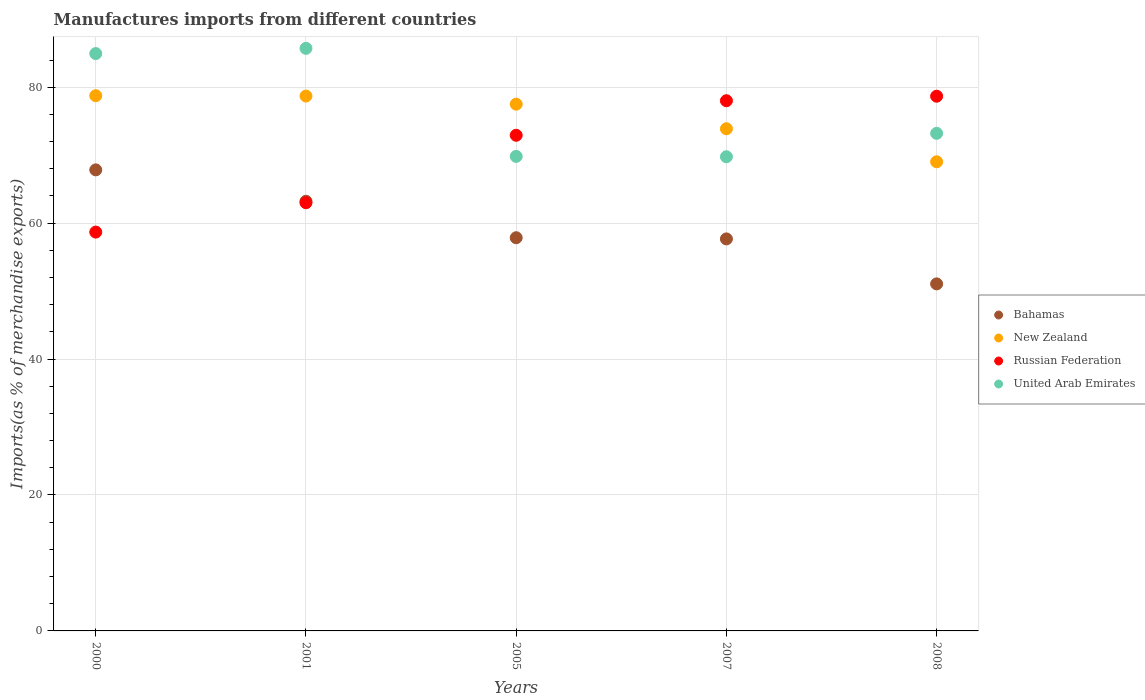What is the percentage of imports to different countries in United Arab Emirates in 2005?
Make the answer very short. 69.82. Across all years, what is the maximum percentage of imports to different countries in New Zealand?
Offer a terse response. 78.75. Across all years, what is the minimum percentage of imports to different countries in United Arab Emirates?
Make the answer very short. 69.77. In which year was the percentage of imports to different countries in Russian Federation maximum?
Provide a succinct answer. 2008. What is the total percentage of imports to different countries in United Arab Emirates in the graph?
Offer a terse response. 383.45. What is the difference between the percentage of imports to different countries in Russian Federation in 2005 and that in 2008?
Provide a succinct answer. -5.75. What is the difference between the percentage of imports to different countries in Bahamas in 2001 and the percentage of imports to different countries in New Zealand in 2008?
Offer a terse response. -5.81. What is the average percentage of imports to different countries in Bahamas per year?
Your answer should be very brief. 59.53. In the year 2000, what is the difference between the percentage of imports to different countries in Russian Federation and percentage of imports to different countries in United Arab Emirates?
Your answer should be very brief. -26.26. In how many years, is the percentage of imports to different countries in Bahamas greater than 4 %?
Give a very brief answer. 5. What is the ratio of the percentage of imports to different countries in Bahamas in 2000 to that in 2001?
Provide a short and direct response. 1.07. Is the difference between the percentage of imports to different countries in Russian Federation in 2000 and 2007 greater than the difference between the percentage of imports to different countries in United Arab Emirates in 2000 and 2007?
Give a very brief answer. No. What is the difference between the highest and the second highest percentage of imports to different countries in United Arab Emirates?
Ensure brevity in your answer.  0.77. What is the difference between the highest and the lowest percentage of imports to different countries in United Arab Emirates?
Provide a succinct answer. 15.95. In how many years, is the percentage of imports to different countries in Russian Federation greater than the average percentage of imports to different countries in Russian Federation taken over all years?
Ensure brevity in your answer.  3. Is it the case that in every year, the sum of the percentage of imports to different countries in Russian Federation and percentage of imports to different countries in United Arab Emirates  is greater than the sum of percentage of imports to different countries in New Zealand and percentage of imports to different countries in Bahamas?
Ensure brevity in your answer.  No. Is it the case that in every year, the sum of the percentage of imports to different countries in Bahamas and percentage of imports to different countries in New Zealand  is greater than the percentage of imports to different countries in Russian Federation?
Keep it short and to the point. Yes. Does the percentage of imports to different countries in United Arab Emirates monotonically increase over the years?
Your answer should be very brief. No. How many years are there in the graph?
Keep it short and to the point. 5. Are the values on the major ticks of Y-axis written in scientific E-notation?
Your answer should be very brief. No. Where does the legend appear in the graph?
Your answer should be very brief. Center right. How are the legend labels stacked?
Give a very brief answer. Vertical. What is the title of the graph?
Your response must be concise. Manufactures imports from different countries. Does "Pakistan" appear as one of the legend labels in the graph?
Ensure brevity in your answer.  No. What is the label or title of the X-axis?
Keep it short and to the point. Years. What is the label or title of the Y-axis?
Your answer should be compact. Imports(as % of merchandise exports). What is the Imports(as % of merchandise exports) of Bahamas in 2000?
Offer a very short reply. 67.84. What is the Imports(as % of merchandise exports) of New Zealand in 2000?
Ensure brevity in your answer.  78.75. What is the Imports(as % of merchandise exports) of Russian Federation in 2000?
Your answer should be very brief. 58.68. What is the Imports(as % of merchandise exports) of United Arab Emirates in 2000?
Offer a terse response. 84.94. What is the Imports(as % of merchandise exports) in Bahamas in 2001?
Provide a succinct answer. 63.22. What is the Imports(as % of merchandise exports) of New Zealand in 2001?
Offer a very short reply. 78.7. What is the Imports(as % of merchandise exports) of Russian Federation in 2001?
Your answer should be compact. 63. What is the Imports(as % of merchandise exports) in United Arab Emirates in 2001?
Keep it short and to the point. 85.72. What is the Imports(as % of merchandise exports) in Bahamas in 2005?
Your answer should be very brief. 57.85. What is the Imports(as % of merchandise exports) in New Zealand in 2005?
Offer a terse response. 77.5. What is the Imports(as % of merchandise exports) of Russian Federation in 2005?
Provide a short and direct response. 72.92. What is the Imports(as % of merchandise exports) in United Arab Emirates in 2005?
Offer a very short reply. 69.82. What is the Imports(as % of merchandise exports) of Bahamas in 2007?
Make the answer very short. 57.68. What is the Imports(as % of merchandise exports) of New Zealand in 2007?
Your answer should be very brief. 73.89. What is the Imports(as % of merchandise exports) of Russian Federation in 2007?
Ensure brevity in your answer.  78.01. What is the Imports(as % of merchandise exports) of United Arab Emirates in 2007?
Your answer should be compact. 69.77. What is the Imports(as % of merchandise exports) of Bahamas in 2008?
Offer a terse response. 51.06. What is the Imports(as % of merchandise exports) in New Zealand in 2008?
Your response must be concise. 69.03. What is the Imports(as % of merchandise exports) in Russian Federation in 2008?
Provide a short and direct response. 78.67. What is the Imports(as % of merchandise exports) in United Arab Emirates in 2008?
Your answer should be very brief. 73.21. Across all years, what is the maximum Imports(as % of merchandise exports) in Bahamas?
Your response must be concise. 67.84. Across all years, what is the maximum Imports(as % of merchandise exports) in New Zealand?
Provide a succinct answer. 78.75. Across all years, what is the maximum Imports(as % of merchandise exports) in Russian Federation?
Your response must be concise. 78.67. Across all years, what is the maximum Imports(as % of merchandise exports) of United Arab Emirates?
Offer a terse response. 85.72. Across all years, what is the minimum Imports(as % of merchandise exports) in Bahamas?
Your answer should be very brief. 51.06. Across all years, what is the minimum Imports(as % of merchandise exports) in New Zealand?
Offer a terse response. 69.03. Across all years, what is the minimum Imports(as % of merchandise exports) of Russian Federation?
Your answer should be compact. 58.68. Across all years, what is the minimum Imports(as % of merchandise exports) in United Arab Emirates?
Ensure brevity in your answer.  69.77. What is the total Imports(as % of merchandise exports) in Bahamas in the graph?
Make the answer very short. 297.65. What is the total Imports(as % of merchandise exports) of New Zealand in the graph?
Keep it short and to the point. 377.86. What is the total Imports(as % of merchandise exports) in Russian Federation in the graph?
Offer a very short reply. 351.29. What is the total Imports(as % of merchandise exports) of United Arab Emirates in the graph?
Your response must be concise. 383.45. What is the difference between the Imports(as % of merchandise exports) in Bahamas in 2000 and that in 2001?
Your answer should be compact. 4.62. What is the difference between the Imports(as % of merchandise exports) of New Zealand in 2000 and that in 2001?
Your answer should be very brief. 0.05. What is the difference between the Imports(as % of merchandise exports) in Russian Federation in 2000 and that in 2001?
Your answer should be very brief. -4.32. What is the difference between the Imports(as % of merchandise exports) in United Arab Emirates in 2000 and that in 2001?
Give a very brief answer. -0.77. What is the difference between the Imports(as % of merchandise exports) in Bahamas in 2000 and that in 2005?
Keep it short and to the point. 9.99. What is the difference between the Imports(as % of merchandise exports) of New Zealand in 2000 and that in 2005?
Provide a succinct answer. 1.25. What is the difference between the Imports(as % of merchandise exports) in Russian Federation in 2000 and that in 2005?
Your answer should be very brief. -14.24. What is the difference between the Imports(as % of merchandise exports) of United Arab Emirates in 2000 and that in 2005?
Your answer should be very brief. 15.13. What is the difference between the Imports(as % of merchandise exports) in Bahamas in 2000 and that in 2007?
Make the answer very short. 10.16. What is the difference between the Imports(as % of merchandise exports) in New Zealand in 2000 and that in 2007?
Give a very brief answer. 4.86. What is the difference between the Imports(as % of merchandise exports) of Russian Federation in 2000 and that in 2007?
Provide a succinct answer. -19.33. What is the difference between the Imports(as % of merchandise exports) in United Arab Emirates in 2000 and that in 2007?
Give a very brief answer. 15.18. What is the difference between the Imports(as % of merchandise exports) in Bahamas in 2000 and that in 2008?
Your answer should be compact. 16.77. What is the difference between the Imports(as % of merchandise exports) in New Zealand in 2000 and that in 2008?
Offer a terse response. 9.72. What is the difference between the Imports(as % of merchandise exports) of Russian Federation in 2000 and that in 2008?
Offer a terse response. -19.99. What is the difference between the Imports(as % of merchandise exports) of United Arab Emirates in 2000 and that in 2008?
Your answer should be very brief. 11.74. What is the difference between the Imports(as % of merchandise exports) of Bahamas in 2001 and that in 2005?
Provide a short and direct response. 5.37. What is the difference between the Imports(as % of merchandise exports) in New Zealand in 2001 and that in 2005?
Keep it short and to the point. 1.2. What is the difference between the Imports(as % of merchandise exports) in Russian Federation in 2001 and that in 2005?
Your answer should be compact. -9.93. What is the difference between the Imports(as % of merchandise exports) in United Arab Emirates in 2001 and that in 2005?
Offer a terse response. 15.9. What is the difference between the Imports(as % of merchandise exports) of Bahamas in 2001 and that in 2007?
Provide a short and direct response. 5.54. What is the difference between the Imports(as % of merchandise exports) of New Zealand in 2001 and that in 2007?
Offer a terse response. 4.81. What is the difference between the Imports(as % of merchandise exports) in Russian Federation in 2001 and that in 2007?
Ensure brevity in your answer.  -15.01. What is the difference between the Imports(as % of merchandise exports) in United Arab Emirates in 2001 and that in 2007?
Ensure brevity in your answer.  15.95. What is the difference between the Imports(as % of merchandise exports) of Bahamas in 2001 and that in 2008?
Offer a very short reply. 12.16. What is the difference between the Imports(as % of merchandise exports) in New Zealand in 2001 and that in 2008?
Make the answer very short. 9.67. What is the difference between the Imports(as % of merchandise exports) of Russian Federation in 2001 and that in 2008?
Provide a short and direct response. -15.68. What is the difference between the Imports(as % of merchandise exports) in United Arab Emirates in 2001 and that in 2008?
Your response must be concise. 12.51. What is the difference between the Imports(as % of merchandise exports) in Bahamas in 2005 and that in 2007?
Provide a succinct answer. 0.17. What is the difference between the Imports(as % of merchandise exports) of New Zealand in 2005 and that in 2007?
Provide a succinct answer. 3.62. What is the difference between the Imports(as % of merchandise exports) in Russian Federation in 2005 and that in 2007?
Provide a short and direct response. -5.08. What is the difference between the Imports(as % of merchandise exports) in United Arab Emirates in 2005 and that in 2007?
Offer a terse response. 0.05. What is the difference between the Imports(as % of merchandise exports) in Bahamas in 2005 and that in 2008?
Offer a terse response. 6.79. What is the difference between the Imports(as % of merchandise exports) in New Zealand in 2005 and that in 2008?
Keep it short and to the point. 8.47. What is the difference between the Imports(as % of merchandise exports) of Russian Federation in 2005 and that in 2008?
Offer a very short reply. -5.75. What is the difference between the Imports(as % of merchandise exports) of United Arab Emirates in 2005 and that in 2008?
Provide a succinct answer. -3.39. What is the difference between the Imports(as % of merchandise exports) of Bahamas in 2007 and that in 2008?
Give a very brief answer. 6.62. What is the difference between the Imports(as % of merchandise exports) of New Zealand in 2007 and that in 2008?
Provide a short and direct response. 4.86. What is the difference between the Imports(as % of merchandise exports) of Russian Federation in 2007 and that in 2008?
Keep it short and to the point. -0.66. What is the difference between the Imports(as % of merchandise exports) in United Arab Emirates in 2007 and that in 2008?
Make the answer very short. -3.44. What is the difference between the Imports(as % of merchandise exports) in Bahamas in 2000 and the Imports(as % of merchandise exports) in New Zealand in 2001?
Ensure brevity in your answer.  -10.86. What is the difference between the Imports(as % of merchandise exports) of Bahamas in 2000 and the Imports(as % of merchandise exports) of Russian Federation in 2001?
Offer a very short reply. 4.84. What is the difference between the Imports(as % of merchandise exports) in Bahamas in 2000 and the Imports(as % of merchandise exports) in United Arab Emirates in 2001?
Your answer should be compact. -17.88. What is the difference between the Imports(as % of merchandise exports) in New Zealand in 2000 and the Imports(as % of merchandise exports) in Russian Federation in 2001?
Provide a short and direct response. 15.75. What is the difference between the Imports(as % of merchandise exports) of New Zealand in 2000 and the Imports(as % of merchandise exports) of United Arab Emirates in 2001?
Give a very brief answer. -6.97. What is the difference between the Imports(as % of merchandise exports) in Russian Federation in 2000 and the Imports(as % of merchandise exports) in United Arab Emirates in 2001?
Provide a succinct answer. -27.03. What is the difference between the Imports(as % of merchandise exports) in Bahamas in 2000 and the Imports(as % of merchandise exports) in New Zealand in 2005?
Keep it short and to the point. -9.67. What is the difference between the Imports(as % of merchandise exports) in Bahamas in 2000 and the Imports(as % of merchandise exports) in Russian Federation in 2005?
Ensure brevity in your answer.  -5.09. What is the difference between the Imports(as % of merchandise exports) in Bahamas in 2000 and the Imports(as % of merchandise exports) in United Arab Emirates in 2005?
Your answer should be compact. -1.98. What is the difference between the Imports(as % of merchandise exports) of New Zealand in 2000 and the Imports(as % of merchandise exports) of Russian Federation in 2005?
Provide a succinct answer. 5.82. What is the difference between the Imports(as % of merchandise exports) of New Zealand in 2000 and the Imports(as % of merchandise exports) of United Arab Emirates in 2005?
Keep it short and to the point. 8.93. What is the difference between the Imports(as % of merchandise exports) of Russian Federation in 2000 and the Imports(as % of merchandise exports) of United Arab Emirates in 2005?
Your response must be concise. -11.14. What is the difference between the Imports(as % of merchandise exports) in Bahamas in 2000 and the Imports(as % of merchandise exports) in New Zealand in 2007?
Provide a succinct answer. -6.05. What is the difference between the Imports(as % of merchandise exports) of Bahamas in 2000 and the Imports(as % of merchandise exports) of Russian Federation in 2007?
Provide a succinct answer. -10.17. What is the difference between the Imports(as % of merchandise exports) of Bahamas in 2000 and the Imports(as % of merchandise exports) of United Arab Emirates in 2007?
Provide a short and direct response. -1.93. What is the difference between the Imports(as % of merchandise exports) in New Zealand in 2000 and the Imports(as % of merchandise exports) in Russian Federation in 2007?
Give a very brief answer. 0.74. What is the difference between the Imports(as % of merchandise exports) of New Zealand in 2000 and the Imports(as % of merchandise exports) of United Arab Emirates in 2007?
Give a very brief answer. 8.98. What is the difference between the Imports(as % of merchandise exports) in Russian Federation in 2000 and the Imports(as % of merchandise exports) in United Arab Emirates in 2007?
Your answer should be very brief. -11.08. What is the difference between the Imports(as % of merchandise exports) in Bahamas in 2000 and the Imports(as % of merchandise exports) in New Zealand in 2008?
Give a very brief answer. -1.19. What is the difference between the Imports(as % of merchandise exports) of Bahamas in 2000 and the Imports(as % of merchandise exports) of Russian Federation in 2008?
Provide a succinct answer. -10.84. What is the difference between the Imports(as % of merchandise exports) of Bahamas in 2000 and the Imports(as % of merchandise exports) of United Arab Emirates in 2008?
Provide a short and direct response. -5.37. What is the difference between the Imports(as % of merchandise exports) in New Zealand in 2000 and the Imports(as % of merchandise exports) in Russian Federation in 2008?
Offer a terse response. 0.07. What is the difference between the Imports(as % of merchandise exports) of New Zealand in 2000 and the Imports(as % of merchandise exports) of United Arab Emirates in 2008?
Make the answer very short. 5.54. What is the difference between the Imports(as % of merchandise exports) in Russian Federation in 2000 and the Imports(as % of merchandise exports) in United Arab Emirates in 2008?
Provide a short and direct response. -14.53. What is the difference between the Imports(as % of merchandise exports) of Bahamas in 2001 and the Imports(as % of merchandise exports) of New Zealand in 2005?
Offer a terse response. -14.28. What is the difference between the Imports(as % of merchandise exports) in Bahamas in 2001 and the Imports(as % of merchandise exports) in Russian Federation in 2005?
Provide a short and direct response. -9.71. What is the difference between the Imports(as % of merchandise exports) in Bahamas in 2001 and the Imports(as % of merchandise exports) in United Arab Emirates in 2005?
Offer a very short reply. -6.6. What is the difference between the Imports(as % of merchandise exports) of New Zealand in 2001 and the Imports(as % of merchandise exports) of Russian Federation in 2005?
Offer a terse response. 5.77. What is the difference between the Imports(as % of merchandise exports) of New Zealand in 2001 and the Imports(as % of merchandise exports) of United Arab Emirates in 2005?
Keep it short and to the point. 8.88. What is the difference between the Imports(as % of merchandise exports) of Russian Federation in 2001 and the Imports(as % of merchandise exports) of United Arab Emirates in 2005?
Give a very brief answer. -6.82. What is the difference between the Imports(as % of merchandise exports) of Bahamas in 2001 and the Imports(as % of merchandise exports) of New Zealand in 2007?
Your response must be concise. -10.67. What is the difference between the Imports(as % of merchandise exports) in Bahamas in 2001 and the Imports(as % of merchandise exports) in Russian Federation in 2007?
Give a very brief answer. -14.79. What is the difference between the Imports(as % of merchandise exports) of Bahamas in 2001 and the Imports(as % of merchandise exports) of United Arab Emirates in 2007?
Offer a very short reply. -6.55. What is the difference between the Imports(as % of merchandise exports) of New Zealand in 2001 and the Imports(as % of merchandise exports) of Russian Federation in 2007?
Your answer should be very brief. 0.69. What is the difference between the Imports(as % of merchandise exports) in New Zealand in 2001 and the Imports(as % of merchandise exports) in United Arab Emirates in 2007?
Provide a succinct answer. 8.93. What is the difference between the Imports(as % of merchandise exports) in Russian Federation in 2001 and the Imports(as % of merchandise exports) in United Arab Emirates in 2007?
Your response must be concise. -6.77. What is the difference between the Imports(as % of merchandise exports) of Bahamas in 2001 and the Imports(as % of merchandise exports) of New Zealand in 2008?
Ensure brevity in your answer.  -5.81. What is the difference between the Imports(as % of merchandise exports) of Bahamas in 2001 and the Imports(as % of merchandise exports) of Russian Federation in 2008?
Provide a short and direct response. -15.46. What is the difference between the Imports(as % of merchandise exports) of Bahamas in 2001 and the Imports(as % of merchandise exports) of United Arab Emirates in 2008?
Offer a terse response. -9.99. What is the difference between the Imports(as % of merchandise exports) of New Zealand in 2001 and the Imports(as % of merchandise exports) of Russian Federation in 2008?
Your answer should be very brief. 0.02. What is the difference between the Imports(as % of merchandise exports) in New Zealand in 2001 and the Imports(as % of merchandise exports) in United Arab Emirates in 2008?
Ensure brevity in your answer.  5.49. What is the difference between the Imports(as % of merchandise exports) of Russian Federation in 2001 and the Imports(as % of merchandise exports) of United Arab Emirates in 2008?
Give a very brief answer. -10.21. What is the difference between the Imports(as % of merchandise exports) of Bahamas in 2005 and the Imports(as % of merchandise exports) of New Zealand in 2007?
Your answer should be compact. -16.04. What is the difference between the Imports(as % of merchandise exports) in Bahamas in 2005 and the Imports(as % of merchandise exports) in Russian Federation in 2007?
Offer a very short reply. -20.16. What is the difference between the Imports(as % of merchandise exports) of Bahamas in 2005 and the Imports(as % of merchandise exports) of United Arab Emirates in 2007?
Provide a short and direct response. -11.91. What is the difference between the Imports(as % of merchandise exports) of New Zealand in 2005 and the Imports(as % of merchandise exports) of Russian Federation in 2007?
Your answer should be very brief. -0.51. What is the difference between the Imports(as % of merchandise exports) of New Zealand in 2005 and the Imports(as % of merchandise exports) of United Arab Emirates in 2007?
Offer a terse response. 7.74. What is the difference between the Imports(as % of merchandise exports) of Russian Federation in 2005 and the Imports(as % of merchandise exports) of United Arab Emirates in 2007?
Provide a succinct answer. 3.16. What is the difference between the Imports(as % of merchandise exports) of Bahamas in 2005 and the Imports(as % of merchandise exports) of New Zealand in 2008?
Give a very brief answer. -11.18. What is the difference between the Imports(as % of merchandise exports) of Bahamas in 2005 and the Imports(as % of merchandise exports) of Russian Federation in 2008?
Provide a succinct answer. -20.82. What is the difference between the Imports(as % of merchandise exports) in Bahamas in 2005 and the Imports(as % of merchandise exports) in United Arab Emirates in 2008?
Give a very brief answer. -15.36. What is the difference between the Imports(as % of merchandise exports) in New Zealand in 2005 and the Imports(as % of merchandise exports) in Russian Federation in 2008?
Your answer should be very brief. -1.17. What is the difference between the Imports(as % of merchandise exports) of New Zealand in 2005 and the Imports(as % of merchandise exports) of United Arab Emirates in 2008?
Your response must be concise. 4.29. What is the difference between the Imports(as % of merchandise exports) of Russian Federation in 2005 and the Imports(as % of merchandise exports) of United Arab Emirates in 2008?
Offer a very short reply. -0.28. What is the difference between the Imports(as % of merchandise exports) of Bahamas in 2007 and the Imports(as % of merchandise exports) of New Zealand in 2008?
Give a very brief answer. -11.35. What is the difference between the Imports(as % of merchandise exports) in Bahamas in 2007 and the Imports(as % of merchandise exports) in Russian Federation in 2008?
Provide a succinct answer. -21. What is the difference between the Imports(as % of merchandise exports) in Bahamas in 2007 and the Imports(as % of merchandise exports) in United Arab Emirates in 2008?
Your answer should be very brief. -15.53. What is the difference between the Imports(as % of merchandise exports) of New Zealand in 2007 and the Imports(as % of merchandise exports) of Russian Federation in 2008?
Give a very brief answer. -4.79. What is the difference between the Imports(as % of merchandise exports) of New Zealand in 2007 and the Imports(as % of merchandise exports) of United Arab Emirates in 2008?
Offer a very short reply. 0.68. What is the difference between the Imports(as % of merchandise exports) of Russian Federation in 2007 and the Imports(as % of merchandise exports) of United Arab Emirates in 2008?
Your answer should be compact. 4.8. What is the average Imports(as % of merchandise exports) of Bahamas per year?
Give a very brief answer. 59.53. What is the average Imports(as % of merchandise exports) in New Zealand per year?
Provide a short and direct response. 75.57. What is the average Imports(as % of merchandise exports) in Russian Federation per year?
Provide a succinct answer. 70.26. What is the average Imports(as % of merchandise exports) in United Arab Emirates per year?
Offer a terse response. 76.69. In the year 2000, what is the difference between the Imports(as % of merchandise exports) of Bahamas and Imports(as % of merchandise exports) of New Zealand?
Keep it short and to the point. -10.91. In the year 2000, what is the difference between the Imports(as % of merchandise exports) in Bahamas and Imports(as % of merchandise exports) in Russian Federation?
Ensure brevity in your answer.  9.16. In the year 2000, what is the difference between the Imports(as % of merchandise exports) of Bahamas and Imports(as % of merchandise exports) of United Arab Emirates?
Your answer should be compact. -17.11. In the year 2000, what is the difference between the Imports(as % of merchandise exports) of New Zealand and Imports(as % of merchandise exports) of Russian Federation?
Make the answer very short. 20.07. In the year 2000, what is the difference between the Imports(as % of merchandise exports) in New Zealand and Imports(as % of merchandise exports) in United Arab Emirates?
Make the answer very short. -6.2. In the year 2000, what is the difference between the Imports(as % of merchandise exports) in Russian Federation and Imports(as % of merchandise exports) in United Arab Emirates?
Keep it short and to the point. -26.26. In the year 2001, what is the difference between the Imports(as % of merchandise exports) of Bahamas and Imports(as % of merchandise exports) of New Zealand?
Your response must be concise. -15.48. In the year 2001, what is the difference between the Imports(as % of merchandise exports) in Bahamas and Imports(as % of merchandise exports) in Russian Federation?
Your answer should be compact. 0.22. In the year 2001, what is the difference between the Imports(as % of merchandise exports) in Bahamas and Imports(as % of merchandise exports) in United Arab Emirates?
Provide a succinct answer. -22.5. In the year 2001, what is the difference between the Imports(as % of merchandise exports) in New Zealand and Imports(as % of merchandise exports) in Russian Federation?
Offer a very short reply. 15.7. In the year 2001, what is the difference between the Imports(as % of merchandise exports) in New Zealand and Imports(as % of merchandise exports) in United Arab Emirates?
Offer a terse response. -7.02. In the year 2001, what is the difference between the Imports(as % of merchandise exports) of Russian Federation and Imports(as % of merchandise exports) of United Arab Emirates?
Offer a very short reply. -22.72. In the year 2005, what is the difference between the Imports(as % of merchandise exports) in Bahamas and Imports(as % of merchandise exports) in New Zealand?
Keep it short and to the point. -19.65. In the year 2005, what is the difference between the Imports(as % of merchandise exports) of Bahamas and Imports(as % of merchandise exports) of Russian Federation?
Make the answer very short. -15.07. In the year 2005, what is the difference between the Imports(as % of merchandise exports) in Bahamas and Imports(as % of merchandise exports) in United Arab Emirates?
Offer a terse response. -11.97. In the year 2005, what is the difference between the Imports(as % of merchandise exports) of New Zealand and Imports(as % of merchandise exports) of Russian Federation?
Your answer should be compact. 4.58. In the year 2005, what is the difference between the Imports(as % of merchandise exports) of New Zealand and Imports(as % of merchandise exports) of United Arab Emirates?
Keep it short and to the point. 7.68. In the year 2005, what is the difference between the Imports(as % of merchandise exports) of Russian Federation and Imports(as % of merchandise exports) of United Arab Emirates?
Your response must be concise. 3.11. In the year 2007, what is the difference between the Imports(as % of merchandise exports) of Bahamas and Imports(as % of merchandise exports) of New Zealand?
Your response must be concise. -16.21. In the year 2007, what is the difference between the Imports(as % of merchandise exports) in Bahamas and Imports(as % of merchandise exports) in Russian Federation?
Provide a short and direct response. -20.33. In the year 2007, what is the difference between the Imports(as % of merchandise exports) in Bahamas and Imports(as % of merchandise exports) in United Arab Emirates?
Offer a terse response. -12.09. In the year 2007, what is the difference between the Imports(as % of merchandise exports) of New Zealand and Imports(as % of merchandise exports) of Russian Federation?
Offer a very short reply. -4.12. In the year 2007, what is the difference between the Imports(as % of merchandise exports) in New Zealand and Imports(as % of merchandise exports) in United Arab Emirates?
Provide a succinct answer. 4.12. In the year 2007, what is the difference between the Imports(as % of merchandise exports) of Russian Federation and Imports(as % of merchandise exports) of United Arab Emirates?
Offer a very short reply. 8.24. In the year 2008, what is the difference between the Imports(as % of merchandise exports) in Bahamas and Imports(as % of merchandise exports) in New Zealand?
Make the answer very short. -17.97. In the year 2008, what is the difference between the Imports(as % of merchandise exports) of Bahamas and Imports(as % of merchandise exports) of Russian Federation?
Your response must be concise. -27.61. In the year 2008, what is the difference between the Imports(as % of merchandise exports) in Bahamas and Imports(as % of merchandise exports) in United Arab Emirates?
Ensure brevity in your answer.  -22.15. In the year 2008, what is the difference between the Imports(as % of merchandise exports) of New Zealand and Imports(as % of merchandise exports) of Russian Federation?
Make the answer very short. -9.65. In the year 2008, what is the difference between the Imports(as % of merchandise exports) of New Zealand and Imports(as % of merchandise exports) of United Arab Emirates?
Offer a terse response. -4.18. In the year 2008, what is the difference between the Imports(as % of merchandise exports) of Russian Federation and Imports(as % of merchandise exports) of United Arab Emirates?
Give a very brief answer. 5.47. What is the ratio of the Imports(as % of merchandise exports) of Bahamas in 2000 to that in 2001?
Give a very brief answer. 1.07. What is the ratio of the Imports(as % of merchandise exports) in Russian Federation in 2000 to that in 2001?
Make the answer very short. 0.93. What is the ratio of the Imports(as % of merchandise exports) of Bahamas in 2000 to that in 2005?
Provide a short and direct response. 1.17. What is the ratio of the Imports(as % of merchandise exports) of New Zealand in 2000 to that in 2005?
Provide a succinct answer. 1.02. What is the ratio of the Imports(as % of merchandise exports) of Russian Federation in 2000 to that in 2005?
Make the answer very short. 0.8. What is the ratio of the Imports(as % of merchandise exports) in United Arab Emirates in 2000 to that in 2005?
Keep it short and to the point. 1.22. What is the ratio of the Imports(as % of merchandise exports) of Bahamas in 2000 to that in 2007?
Keep it short and to the point. 1.18. What is the ratio of the Imports(as % of merchandise exports) in New Zealand in 2000 to that in 2007?
Make the answer very short. 1.07. What is the ratio of the Imports(as % of merchandise exports) of Russian Federation in 2000 to that in 2007?
Your response must be concise. 0.75. What is the ratio of the Imports(as % of merchandise exports) in United Arab Emirates in 2000 to that in 2007?
Give a very brief answer. 1.22. What is the ratio of the Imports(as % of merchandise exports) in Bahamas in 2000 to that in 2008?
Your answer should be very brief. 1.33. What is the ratio of the Imports(as % of merchandise exports) of New Zealand in 2000 to that in 2008?
Offer a very short reply. 1.14. What is the ratio of the Imports(as % of merchandise exports) in Russian Federation in 2000 to that in 2008?
Make the answer very short. 0.75. What is the ratio of the Imports(as % of merchandise exports) of United Arab Emirates in 2000 to that in 2008?
Your answer should be compact. 1.16. What is the ratio of the Imports(as % of merchandise exports) in Bahamas in 2001 to that in 2005?
Your response must be concise. 1.09. What is the ratio of the Imports(as % of merchandise exports) in New Zealand in 2001 to that in 2005?
Your answer should be compact. 1.02. What is the ratio of the Imports(as % of merchandise exports) in Russian Federation in 2001 to that in 2005?
Your answer should be very brief. 0.86. What is the ratio of the Imports(as % of merchandise exports) in United Arab Emirates in 2001 to that in 2005?
Your answer should be compact. 1.23. What is the ratio of the Imports(as % of merchandise exports) of Bahamas in 2001 to that in 2007?
Offer a terse response. 1.1. What is the ratio of the Imports(as % of merchandise exports) of New Zealand in 2001 to that in 2007?
Your answer should be compact. 1.07. What is the ratio of the Imports(as % of merchandise exports) of Russian Federation in 2001 to that in 2007?
Your response must be concise. 0.81. What is the ratio of the Imports(as % of merchandise exports) of United Arab Emirates in 2001 to that in 2007?
Provide a succinct answer. 1.23. What is the ratio of the Imports(as % of merchandise exports) in Bahamas in 2001 to that in 2008?
Give a very brief answer. 1.24. What is the ratio of the Imports(as % of merchandise exports) of New Zealand in 2001 to that in 2008?
Provide a succinct answer. 1.14. What is the ratio of the Imports(as % of merchandise exports) of Russian Federation in 2001 to that in 2008?
Provide a succinct answer. 0.8. What is the ratio of the Imports(as % of merchandise exports) in United Arab Emirates in 2001 to that in 2008?
Provide a succinct answer. 1.17. What is the ratio of the Imports(as % of merchandise exports) of Bahamas in 2005 to that in 2007?
Make the answer very short. 1. What is the ratio of the Imports(as % of merchandise exports) in New Zealand in 2005 to that in 2007?
Keep it short and to the point. 1.05. What is the ratio of the Imports(as % of merchandise exports) of Russian Federation in 2005 to that in 2007?
Your response must be concise. 0.93. What is the ratio of the Imports(as % of merchandise exports) in United Arab Emirates in 2005 to that in 2007?
Your response must be concise. 1. What is the ratio of the Imports(as % of merchandise exports) in Bahamas in 2005 to that in 2008?
Give a very brief answer. 1.13. What is the ratio of the Imports(as % of merchandise exports) of New Zealand in 2005 to that in 2008?
Give a very brief answer. 1.12. What is the ratio of the Imports(as % of merchandise exports) of Russian Federation in 2005 to that in 2008?
Provide a succinct answer. 0.93. What is the ratio of the Imports(as % of merchandise exports) of United Arab Emirates in 2005 to that in 2008?
Ensure brevity in your answer.  0.95. What is the ratio of the Imports(as % of merchandise exports) of Bahamas in 2007 to that in 2008?
Keep it short and to the point. 1.13. What is the ratio of the Imports(as % of merchandise exports) of New Zealand in 2007 to that in 2008?
Your answer should be very brief. 1.07. What is the ratio of the Imports(as % of merchandise exports) of United Arab Emirates in 2007 to that in 2008?
Offer a very short reply. 0.95. What is the difference between the highest and the second highest Imports(as % of merchandise exports) in Bahamas?
Your answer should be very brief. 4.62. What is the difference between the highest and the second highest Imports(as % of merchandise exports) of New Zealand?
Provide a succinct answer. 0.05. What is the difference between the highest and the second highest Imports(as % of merchandise exports) of Russian Federation?
Offer a very short reply. 0.66. What is the difference between the highest and the second highest Imports(as % of merchandise exports) in United Arab Emirates?
Ensure brevity in your answer.  0.77. What is the difference between the highest and the lowest Imports(as % of merchandise exports) in Bahamas?
Keep it short and to the point. 16.77. What is the difference between the highest and the lowest Imports(as % of merchandise exports) in New Zealand?
Offer a very short reply. 9.72. What is the difference between the highest and the lowest Imports(as % of merchandise exports) of Russian Federation?
Your answer should be very brief. 19.99. What is the difference between the highest and the lowest Imports(as % of merchandise exports) of United Arab Emirates?
Your response must be concise. 15.95. 